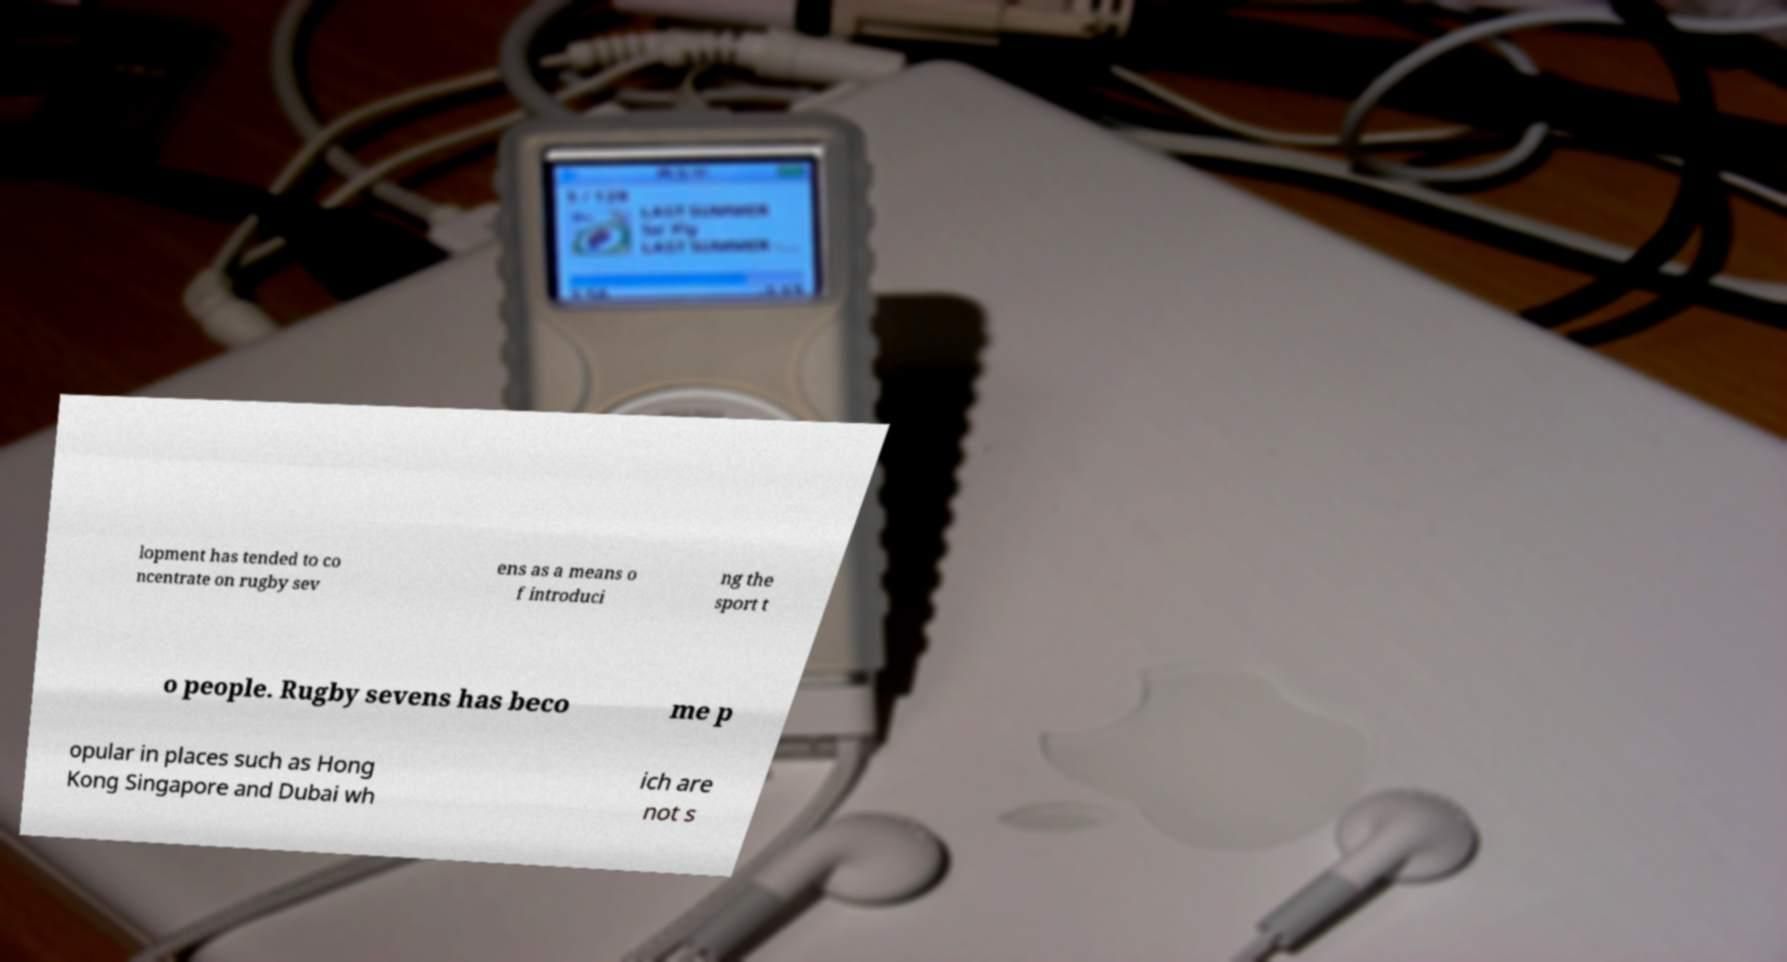What messages or text are displayed in this image? I need them in a readable, typed format. lopment has tended to co ncentrate on rugby sev ens as a means o f introduci ng the sport t o people. Rugby sevens has beco me p opular in places such as Hong Kong Singapore and Dubai wh ich are not s 